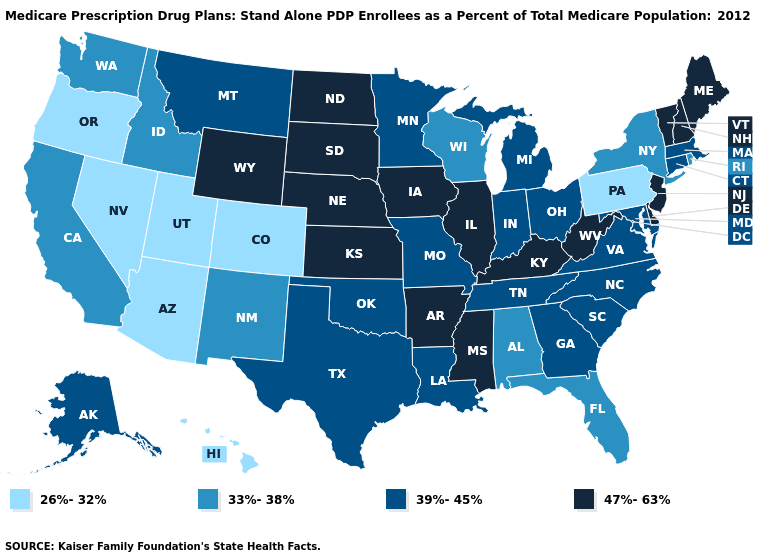Which states hav the highest value in the MidWest?
Keep it brief. Iowa, Illinois, Kansas, North Dakota, Nebraska, South Dakota. Which states have the highest value in the USA?
Give a very brief answer. Arkansas, Delaware, Iowa, Illinois, Kansas, Kentucky, Maine, Mississippi, North Dakota, Nebraska, New Hampshire, New Jersey, South Dakota, Vermont, West Virginia, Wyoming. Name the states that have a value in the range 33%-38%?
Concise answer only. Alabama, California, Florida, Idaho, New Mexico, New York, Rhode Island, Washington, Wisconsin. Name the states that have a value in the range 39%-45%?
Answer briefly. Alaska, Connecticut, Georgia, Indiana, Louisiana, Massachusetts, Maryland, Michigan, Minnesota, Missouri, Montana, North Carolina, Ohio, Oklahoma, South Carolina, Tennessee, Texas, Virginia. Does Massachusetts have the highest value in the Northeast?
Concise answer only. No. What is the value of Michigan?
Concise answer only. 39%-45%. Name the states that have a value in the range 47%-63%?
Be succinct. Arkansas, Delaware, Iowa, Illinois, Kansas, Kentucky, Maine, Mississippi, North Dakota, Nebraska, New Hampshire, New Jersey, South Dakota, Vermont, West Virginia, Wyoming. What is the highest value in the MidWest ?
Answer briefly. 47%-63%. Does the map have missing data?
Keep it brief. No. Does Pennsylvania have the lowest value in the Northeast?
Be succinct. Yes. Which states have the lowest value in the USA?
Quick response, please. Arizona, Colorado, Hawaii, Nevada, Oregon, Pennsylvania, Utah. Does Arizona have the lowest value in the USA?
Answer briefly. Yes. Name the states that have a value in the range 47%-63%?
Quick response, please. Arkansas, Delaware, Iowa, Illinois, Kansas, Kentucky, Maine, Mississippi, North Dakota, Nebraska, New Hampshire, New Jersey, South Dakota, Vermont, West Virginia, Wyoming. What is the value of Arkansas?
Keep it brief. 47%-63%. Name the states that have a value in the range 33%-38%?
Be succinct. Alabama, California, Florida, Idaho, New Mexico, New York, Rhode Island, Washington, Wisconsin. 